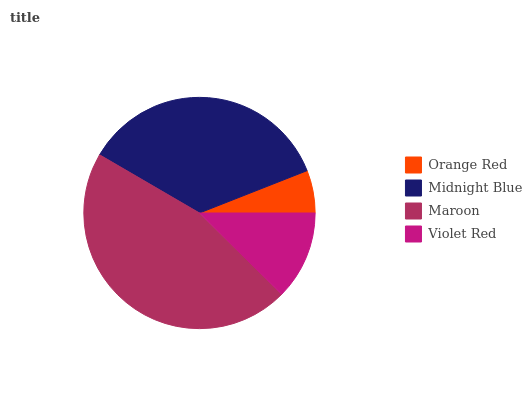Is Orange Red the minimum?
Answer yes or no. Yes. Is Maroon the maximum?
Answer yes or no. Yes. Is Midnight Blue the minimum?
Answer yes or no. No. Is Midnight Blue the maximum?
Answer yes or no. No. Is Midnight Blue greater than Orange Red?
Answer yes or no. Yes. Is Orange Red less than Midnight Blue?
Answer yes or no. Yes. Is Orange Red greater than Midnight Blue?
Answer yes or no. No. Is Midnight Blue less than Orange Red?
Answer yes or no. No. Is Midnight Blue the high median?
Answer yes or no. Yes. Is Violet Red the low median?
Answer yes or no. Yes. Is Violet Red the high median?
Answer yes or no. No. Is Maroon the low median?
Answer yes or no. No. 